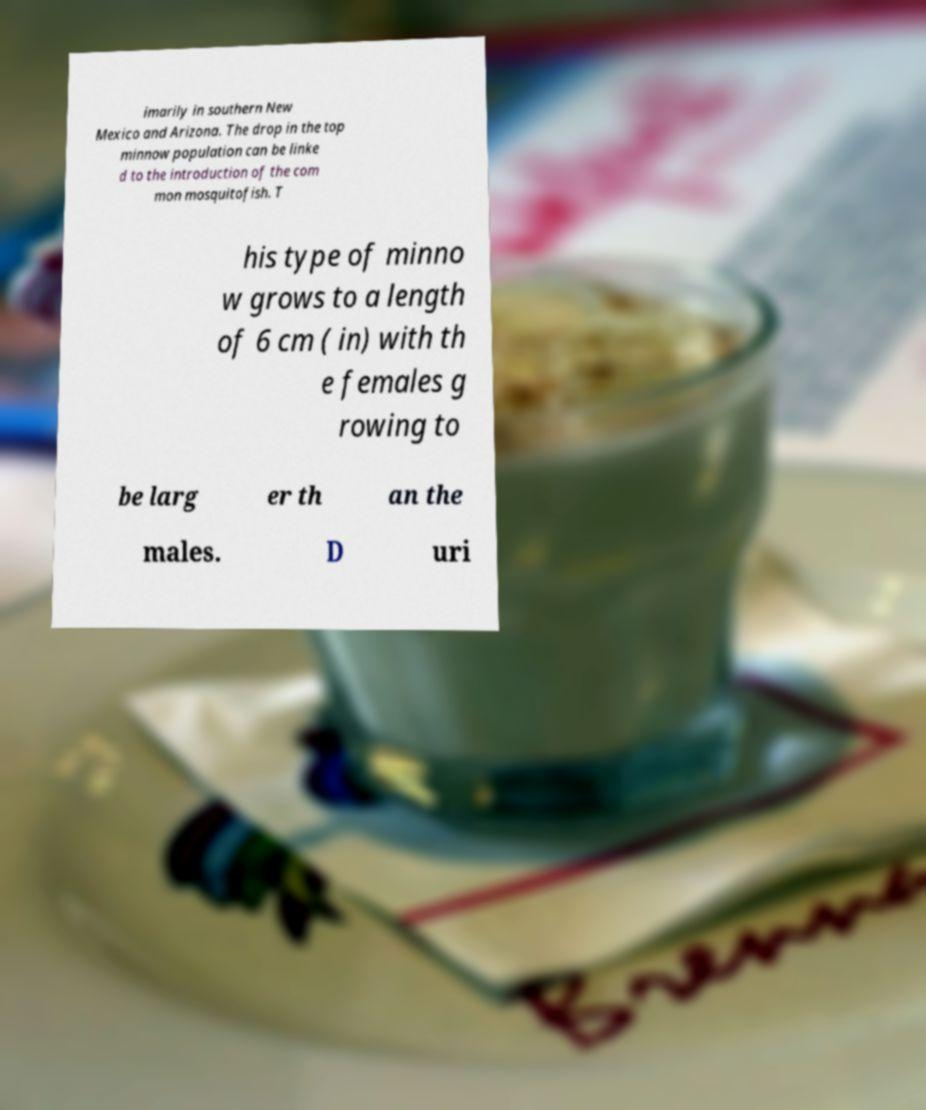Can you read and provide the text displayed in the image?This photo seems to have some interesting text. Can you extract and type it out for me? imarily in southern New Mexico and Arizona. The drop in the top minnow population can be linke d to the introduction of the com mon mosquitofish. T his type of minno w grows to a length of 6 cm ( in) with th e females g rowing to be larg er th an the males. D uri 